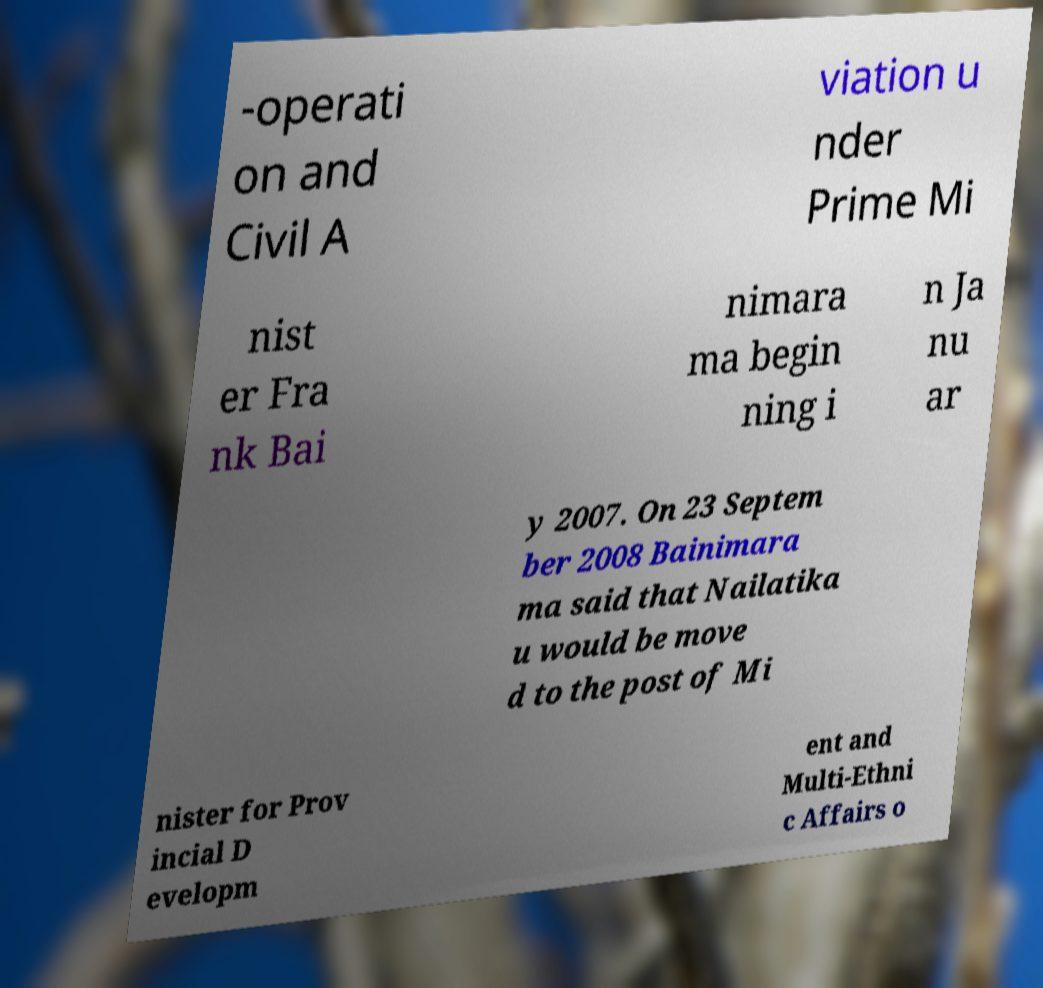Can you accurately transcribe the text from the provided image for me? -operati on and Civil A viation u nder Prime Mi nist er Fra nk Bai nimara ma begin ning i n Ja nu ar y 2007. On 23 Septem ber 2008 Bainimara ma said that Nailatika u would be move d to the post of Mi nister for Prov incial D evelopm ent and Multi-Ethni c Affairs o 